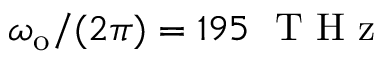Convert formula to latex. <formula><loc_0><loc_0><loc_500><loc_500>\omega _ { o } / ( 2 \pi ) = 1 9 5 \ T H z</formula> 